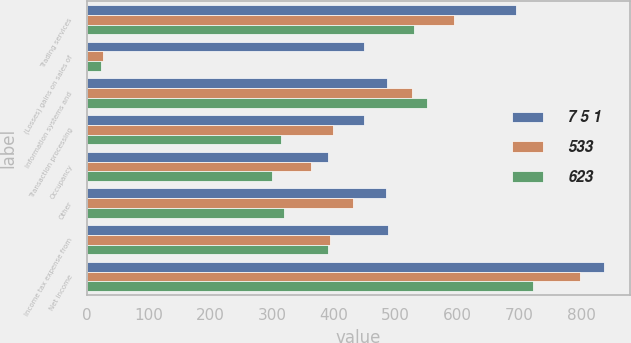Convert chart to OTSL. <chart><loc_0><loc_0><loc_500><loc_500><stacked_bar_chart><ecel><fcel>Trading services<fcel>(Losses) gains on sales of<fcel>Information systems and<fcel>Transaction processing<fcel>Occupancy<fcel>Other<fcel>Income tax expense from<fcel>Net income<nl><fcel>7 5 1<fcel>694<fcel>449<fcel>486<fcel>449<fcel>391<fcel>484<fcel>487<fcel>838<nl><fcel>533<fcel>595<fcel>26<fcel>527<fcel>398<fcel>363<fcel>431<fcel>394<fcel>798<nl><fcel>623<fcel>529<fcel>23<fcel>551<fcel>314<fcel>300<fcel>320<fcel>390<fcel>722<nl></chart> 